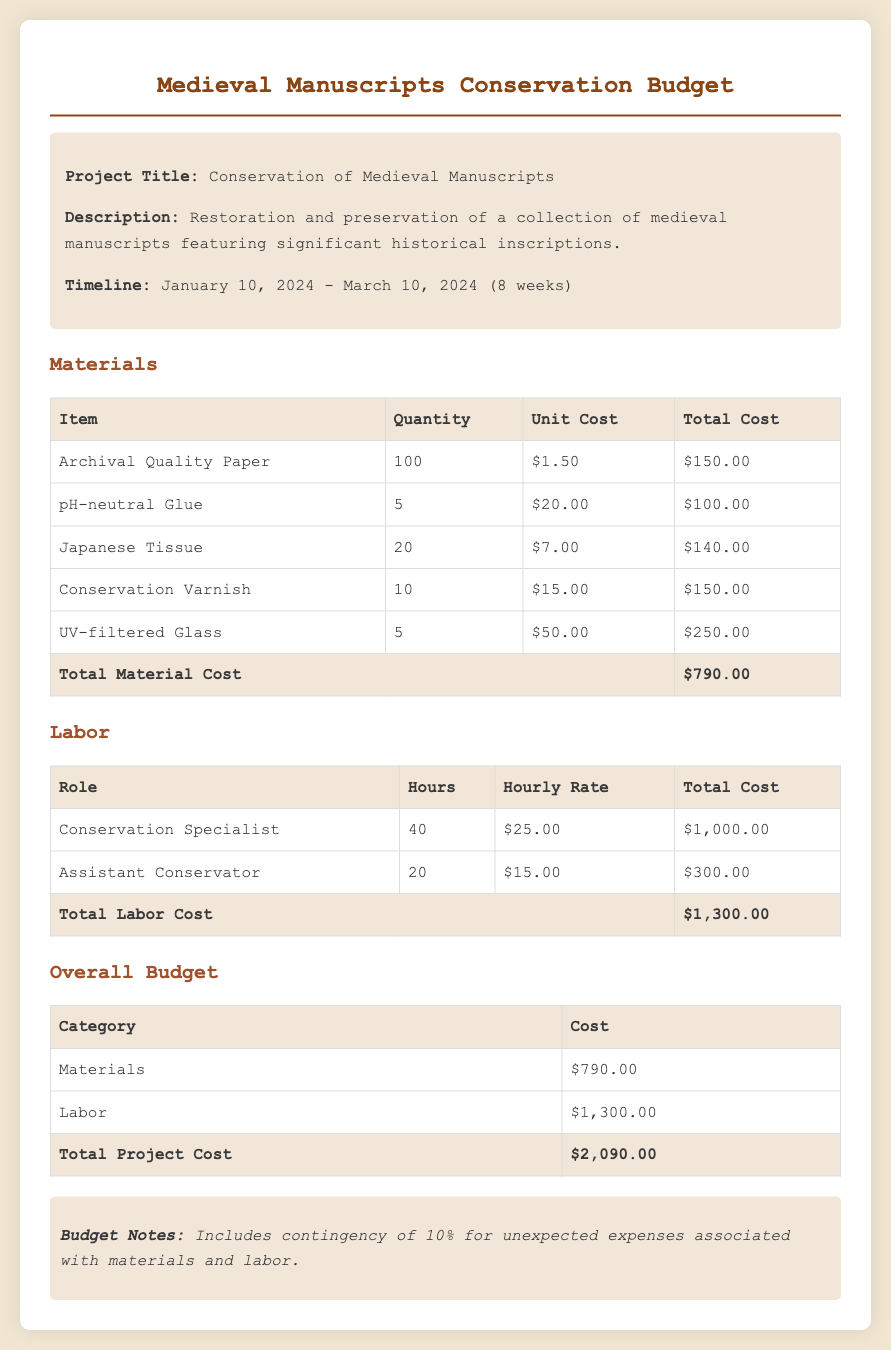What is the project title? The project title is provided in the document under the project information section.
Answer: Conservation of Medieval Manuscripts What is the total material cost? The total material cost can be found in the materials section at the bottom of the table.
Answer: $790.00 How many hours did the Conservation Specialist work? The number of hours worked by the Conservation Specialist is listed in the labor section of the document.
Answer: 40 What is the hourly rate for the Assistant Conservator? The hourly rate for the Assistant Conservator is listed in the labor section, providing the specific amount per hour.
Answer: $15.00 What is the overall project cost? The overall project cost is the total calculated from both materials and labor, summarized at the end of the budget section.
Answer: $2,090.00 What type of glue is listed in the materials? The specific type of glue used in the restoration is detailed in the materials table.
Answer: pH-neutral Glue What contingency percentage is included in the budget? The document notes a contingency percentage for unexpected expenses in the budget notes section.
Answer: 10% How many units of UV-filtered Glass are required? The quantity of UV-filtered Glass needed is specified in the materials section of the document.
Answer: 5 What role has the highest total labor cost? By comparing the total costs in the labor section, one can identify which role had the highest expense.
Answer: Conservation Specialist 